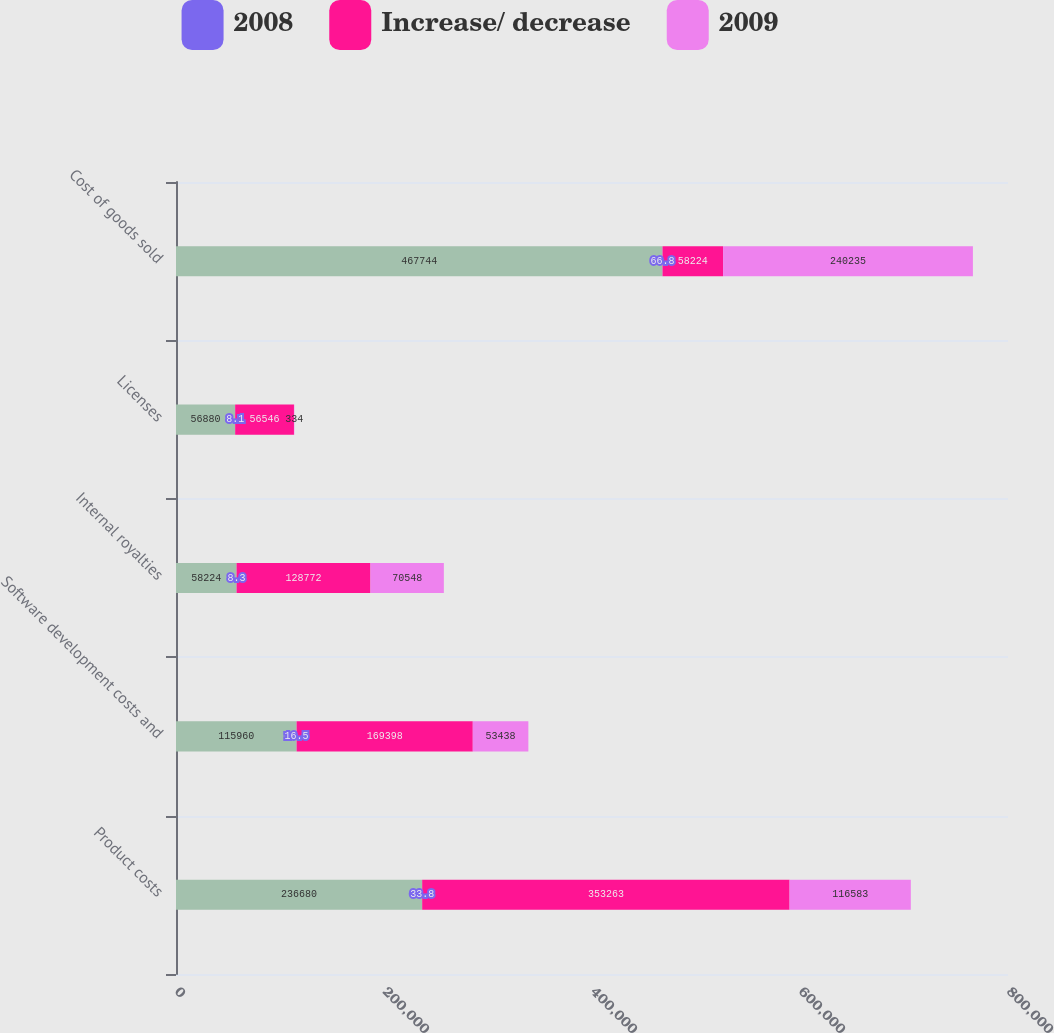Convert chart. <chart><loc_0><loc_0><loc_500><loc_500><stacked_bar_chart><ecel><fcel>Product costs<fcel>Software development costs and<fcel>Internal royalties<fcel>Licenses<fcel>Cost of goods sold<nl><fcel>nan<fcel>236680<fcel>115960<fcel>58224<fcel>56880<fcel>467744<nl><fcel>2008<fcel>33.8<fcel>16.5<fcel>8.3<fcel>8.1<fcel>66.8<nl><fcel>Increase/ decrease<fcel>353263<fcel>169398<fcel>128772<fcel>56546<fcel>58224<nl><fcel>2009<fcel>116583<fcel>53438<fcel>70548<fcel>334<fcel>240235<nl></chart> 